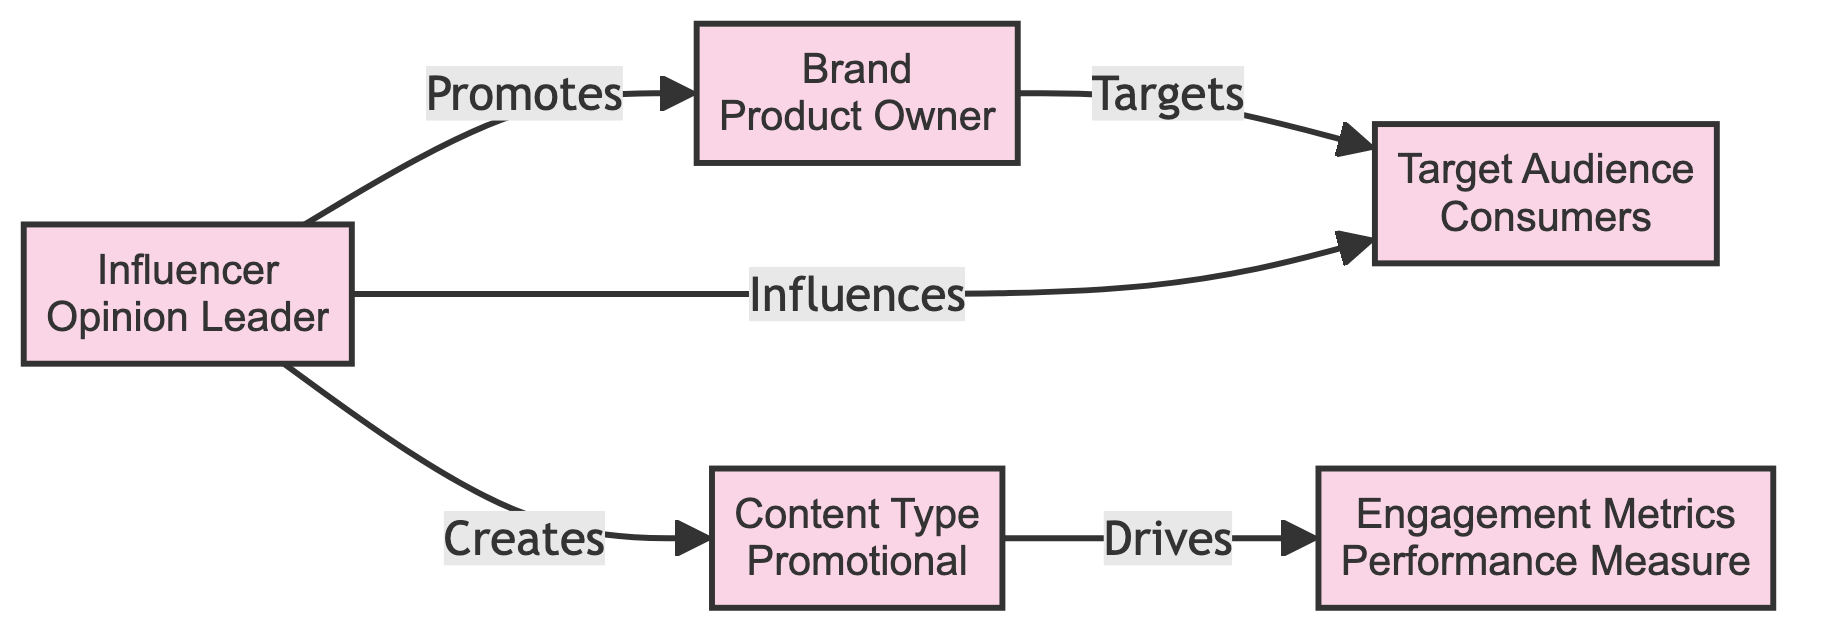What is the type of the Influencer node? The Influencer node is categorized as an "Opinion Leader" based on its attributes.
Answer: Opinion Leader How many nodes are there in total? By counting the nodes in the diagram, we find that there are five distinct nodes.
Answer: 5 What relationship exists between the Brand and the Audience? The Brand targets the Audience, which is indicated by the directed edge from Brand to Audience labeled "Targets."
Answer: Targets Which node is responsible for creating content? The Influencer node has a directed edge to the Content node labeled "Creates," meaning the Influencer is responsible for content creation.
Answer: Influencer What type of content is associated with the Content node? The Content node is identified as "Promotional," as indicated by its attributes.
Answer: Promotional Which metrics do the Engagement node provide? The Engagement node is defined as a "Performance Measure," which clarifies that it provides metrics related to performance.
Answer: Performance Measure What does the Content node drive? The Content node drives Engagement Metrics, as shown by the directed edge from Content to Engagement.
Answer: Engagement Metrics If the Influencer influences the Audience, what impact might this have on the Brand? The influence of the Influencer on the Audience can impact the Brand positively, as a successful Influence can lead to increased engagement and sales for the Brand.
Answer: Positive Impact How many edges are present in the diagram? By examining the connections, there are a total of five edges that illustrate relationships between the nodes.
Answer: 5 